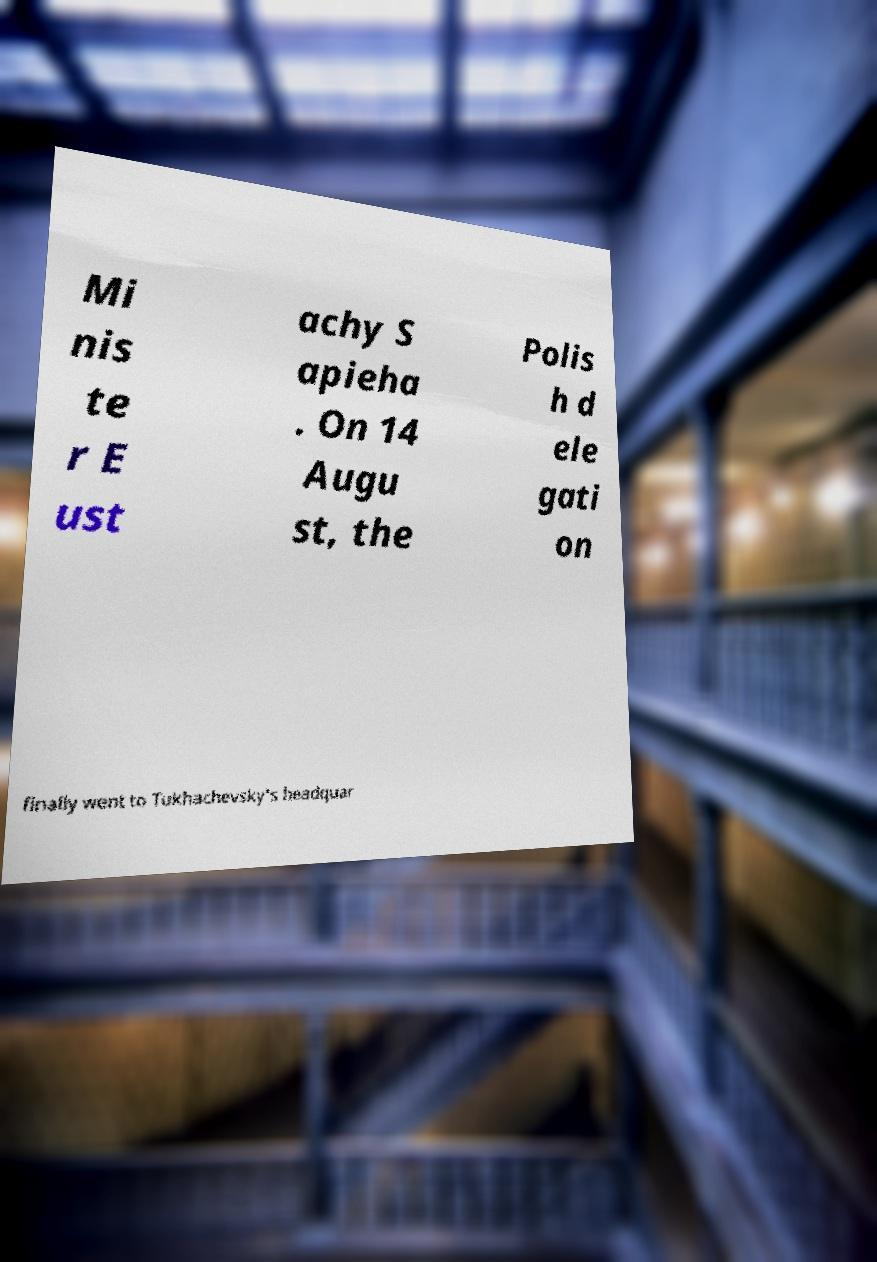Can you read and provide the text displayed in the image?This photo seems to have some interesting text. Can you extract and type it out for me? Mi nis te r E ust achy S apieha . On 14 Augu st, the Polis h d ele gati on finally went to Tukhachevsky's headquar 